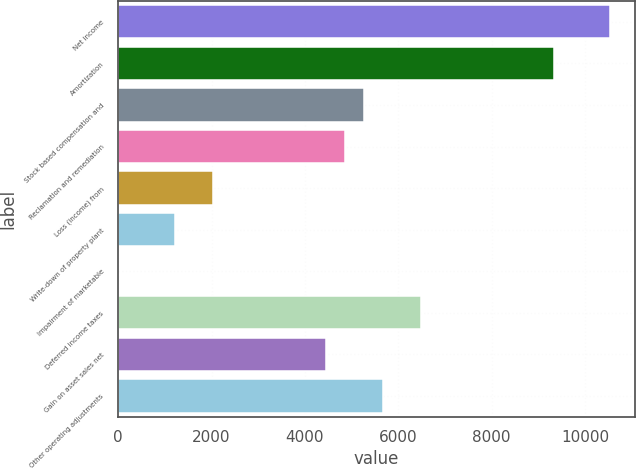Convert chart. <chart><loc_0><loc_0><loc_500><loc_500><bar_chart><fcel>Net income<fcel>Amortization<fcel>Stock based compensation and<fcel>Reclamation and remediation<fcel>Loss (income) from<fcel>Write-down of property plant<fcel>Impairment of marketable<fcel>Deferred income taxes<fcel>Gain on asset sales net<fcel>Other operating adjustments<nl><fcel>10544<fcel>9327.5<fcel>5272.5<fcel>4867<fcel>2028.5<fcel>1217.5<fcel>1<fcel>6489<fcel>4461.5<fcel>5678<nl></chart> 